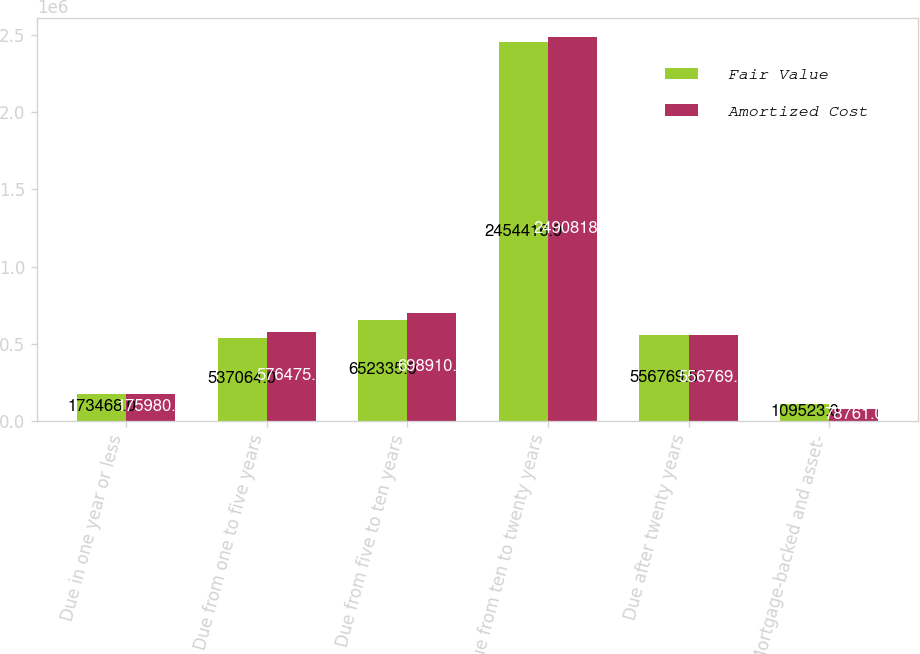Convert chart. <chart><loc_0><loc_0><loc_500><loc_500><stacked_bar_chart><ecel><fcel>Due in one year or less<fcel>Due from one to five years<fcel>Due from five to ten years<fcel>Due from ten to twenty years<fcel>Due after twenty years<fcel>Mortgage-backed and asset-<nl><fcel>Fair Value<fcel>173468<fcel>537064<fcel>652335<fcel>2.45442e+06<fcel>556770<fcel>109523<nl><fcel>Amortized Cost<fcel>175980<fcel>576475<fcel>698910<fcel>2.49082e+06<fcel>556770<fcel>78761<nl></chart> 